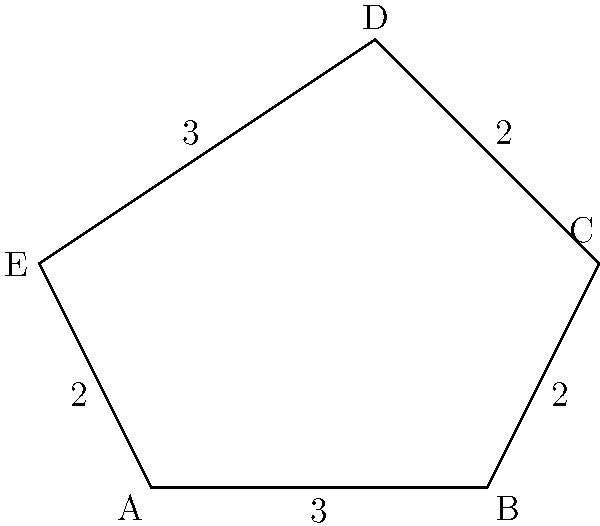A trendy coffee shop is designing a new logo in the shape of a pentagon. The side lengths of the pentagon are 3 cm, 2 cm, 2 cm, 3 cm, and 2 cm, as shown in the diagram. What is the area of this pentagonal logo in square centimeters? To find the area of this irregular pentagon, we can follow these steps:

1) First, we need to divide the pentagon into triangles. We can do this by drawing diagonals from one vertex to all non-adjacent vertices.

2) Let's choose vertex A and draw diagonals AC and AD. This divides the pentagon into three triangles: ABC, ACD, and ADE.

3) Now, we need to find the height of each triangle. We can do this using Heron's formula:

   $A = \sqrt{s(s-a)(s-b)(s-c)}$

   Where $A$ is the area, $s$ is the semi-perimeter $(a+b+c)/2$, and $a$, $b$, and $c$ are the side lengths.

4) For triangle ABC:
   $s = (3+2+3)/2 = 4$
   $A = \sqrt{4(4-3)(4-2)(4-3)} = \sqrt{4 \cdot 1 \cdot 2 \cdot 1} = 2\sqrt{2}$ cm²

5) For triangle ACD:
   $s = (3+2+3)/2 = 4$
   $A = \sqrt{4(4-3)(4-2)(4-3)} = \sqrt{4 \cdot 1 \cdot 2 \cdot 1} = 2\sqrt{2}$ cm²

6) For triangle ADE:
   $s = (2+3+2)/2 = 3.5$
   $A = \sqrt{3.5(3.5-2)(3.5-3)(3.5-2)} = \sqrt{3.5 \cdot 1.5 \cdot 0.5 \cdot 1.5} = \frac{3\sqrt{3}}{2}$ cm²

7) The total area is the sum of these three triangles:
   $A_{total} = 2\sqrt{2} + 2\sqrt{2} + \frac{3\sqrt{3}}{2} = 4\sqrt{2} + \frac{3\sqrt{3}}{2}$ cm²

8) Simplifying:
   $A_{total} \approx 11.16$ cm²
Answer: $4\sqrt{2} + \frac{3\sqrt{3}}{2}$ cm² (or approximately 11.16 cm²) 